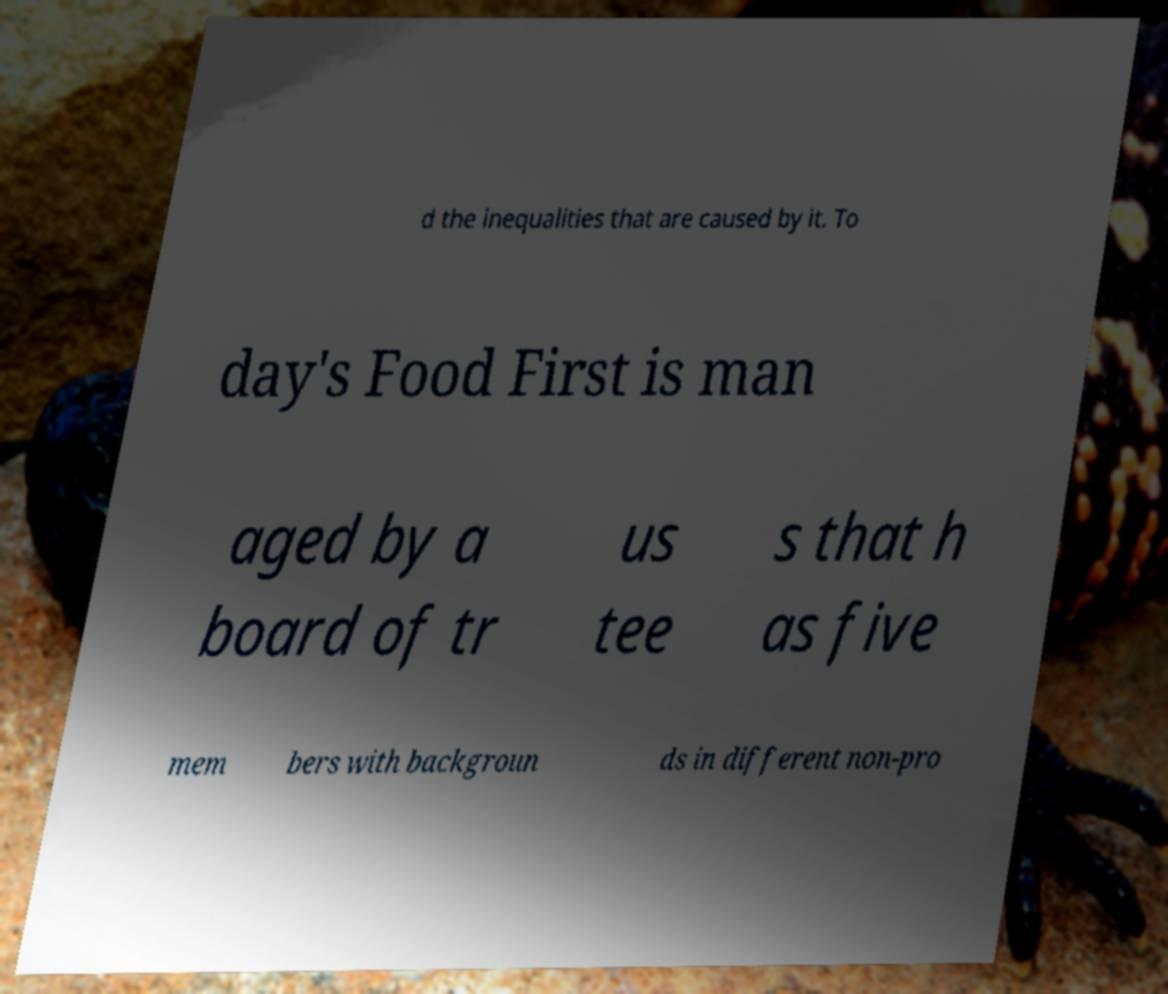What messages or text are displayed in this image? I need them in a readable, typed format. d the inequalities that are caused by it. To day's Food First is man aged by a board of tr us tee s that h as five mem bers with backgroun ds in different non-pro 